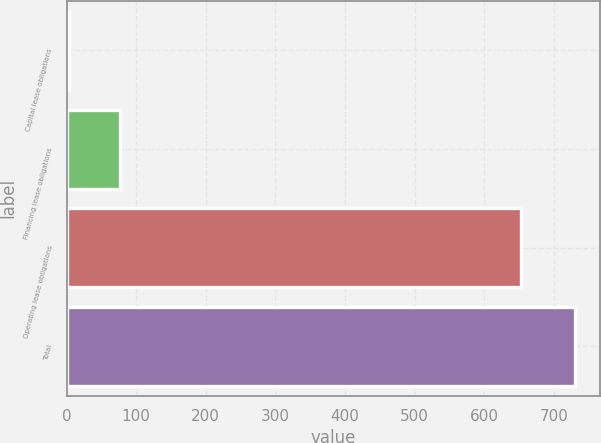Convert chart to OTSL. <chart><loc_0><loc_0><loc_500><loc_500><bar_chart><fcel>Capital lease obligations<fcel>Financing lease obligations<fcel>Operating lease obligations<fcel>Total<nl><fcel>4<fcel>76.6<fcel>653<fcel>730<nl></chart> 